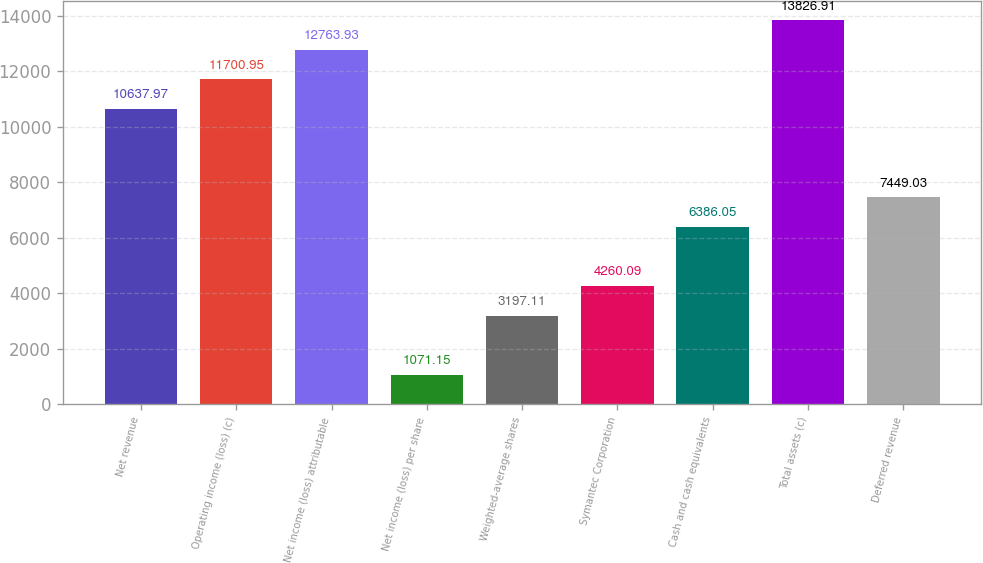<chart> <loc_0><loc_0><loc_500><loc_500><bar_chart><fcel>Net revenue<fcel>Operating income (loss) (c)<fcel>Net income (loss) attributable<fcel>Net income (loss) per share<fcel>Weighted-average shares<fcel>Symantec Corporation<fcel>Cash and cash equivalents<fcel>Total assets (c)<fcel>Deferred revenue<nl><fcel>10638<fcel>11701<fcel>12763.9<fcel>1071.15<fcel>3197.11<fcel>4260.09<fcel>6386.05<fcel>13826.9<fcel>7449.03<nl></chart> 